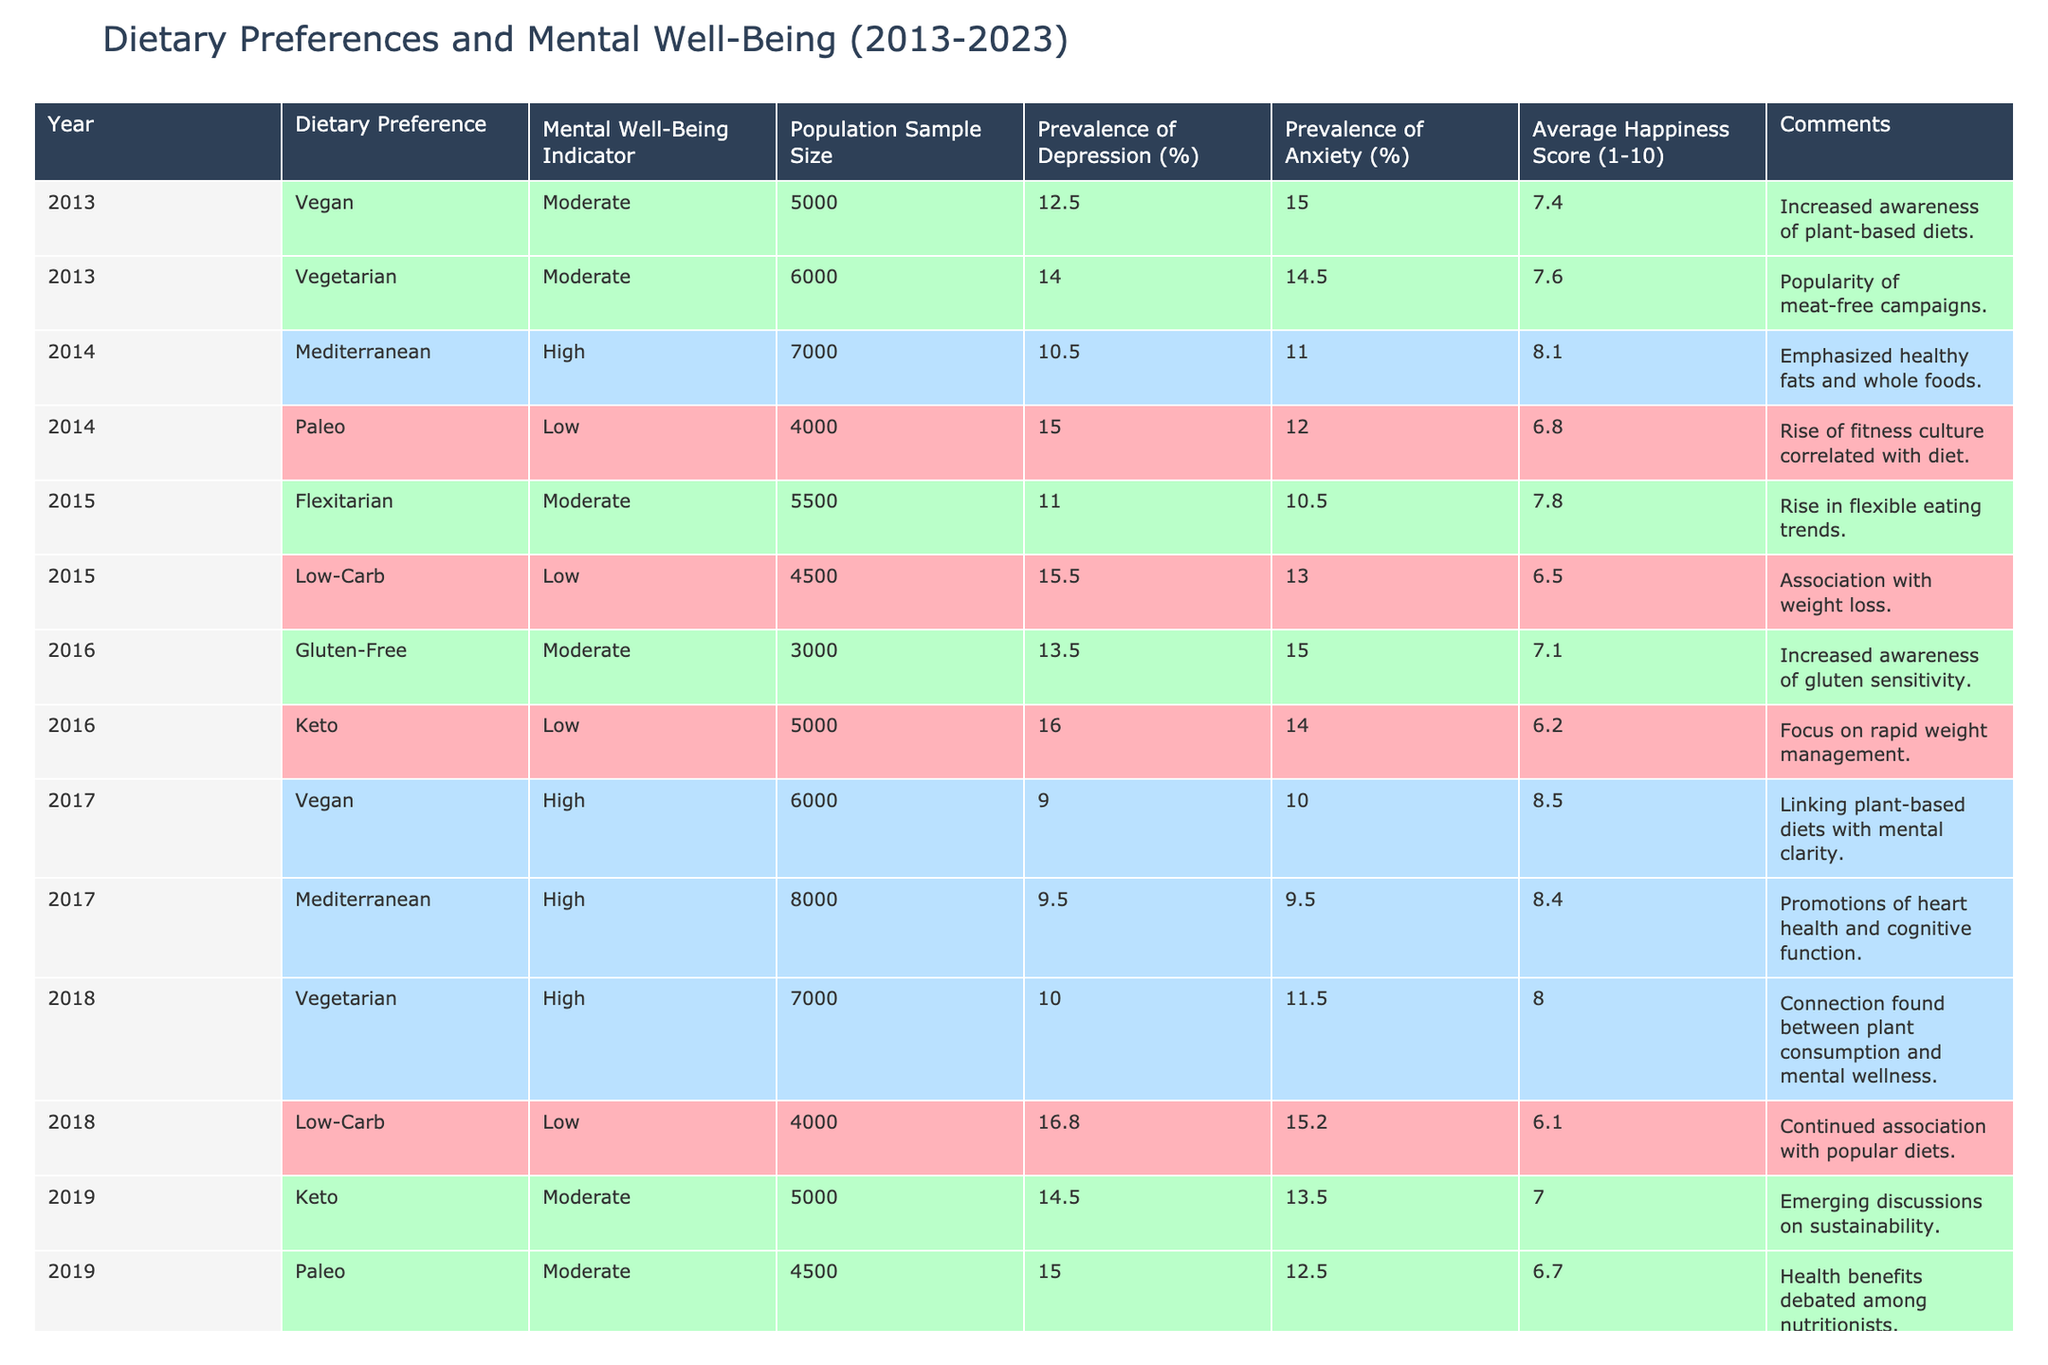What was the average happiness score for the Vegan diet in 2023? From the table, we see the Vegan diet's happiness score in 2023 is 9.0. Therefore, the average happiness score for the Vegan diet in 2023 is simply 9.0.
Answer: 9.0 Which dietary preference had the highest prevalence of depression in 2016? In 2016, the Keto diet had the highest prevalence of depression at 16.0%.
Answer: 16.0% Has the prevalence of anxiety for the Mediterranean diet decreased from 2013 to 2023? In 2013, the Mediterranean diet had a prevalence of anxiety of 11.0%, and in 2023, it decreased to 7.5%. This shows a decrease in the prevalence of anxiety for the Mediterranean diet over the years.
Answer: Yes What is the difference in average happiness scores between the Vegan diet in 2017 and the Vegan diet in 2020? The average happiness score for the Vegan diet in 2017 is 8.5, and in 2020 it is 8.7. The difference is 8.7 - 8.5 = 0.2.
Answer: 0.2 Which dietary preference consistently had a high mental well-being indicator from 2017 to 2023, and what was its indicator in 2023? The Vegan diet maintained a high mental well-being indicator from 2017 to 2023, and its indicator in 2023 is classified as High.
Answer: High Calculate the average prevalence of depression across all dietary preferences in 2021. The prevalence of depression in 2021 is 7.5% (Mediterranean), 11.5% (Gluten-Free), so the average is (7.5 + 11.5) / 2 = 9.5%.
Answer: 9.5% In which year did the Mediterranean diet record the lowest prevalence of depression? The Mediterranean diet recorded the lowest prevalence of depression in 2023, with only 6.0%.
Answer: 2023 Was there an increase in the average happiness score for Vegetarian diets from 2013 to 2018? In 2013, the happiness score for Vegetarian diets was 7.6, and in 2018 it was 8.0. Since 8.0 > 7.6, this indicates an increase in average happiness score during those years.
Answer: Yes What correlation trend can be observed between low-preference diets and mental well-being indicators from 2013 to 2023? Examining the data, it appears low-preference diets generally have lower mental well-being indicators. For instance, the Keto and Low-Carb diets exhibit lower well-being indicators consistently from 2013 to 2023.
Answer: Lower correlation trend What was the change in the prevalence of anxiety for Vegan diets from 2013 to 2023? In 2013, the prevalence of anxiety for Vegan diets was 15.0%, and in 2023 it was 8.0%. The change is 15.0 - 8.0 = 7.0%, indicating a decrease in anxiety prevalence for Vegan diets.
Answer: Decrease of 7.0% 